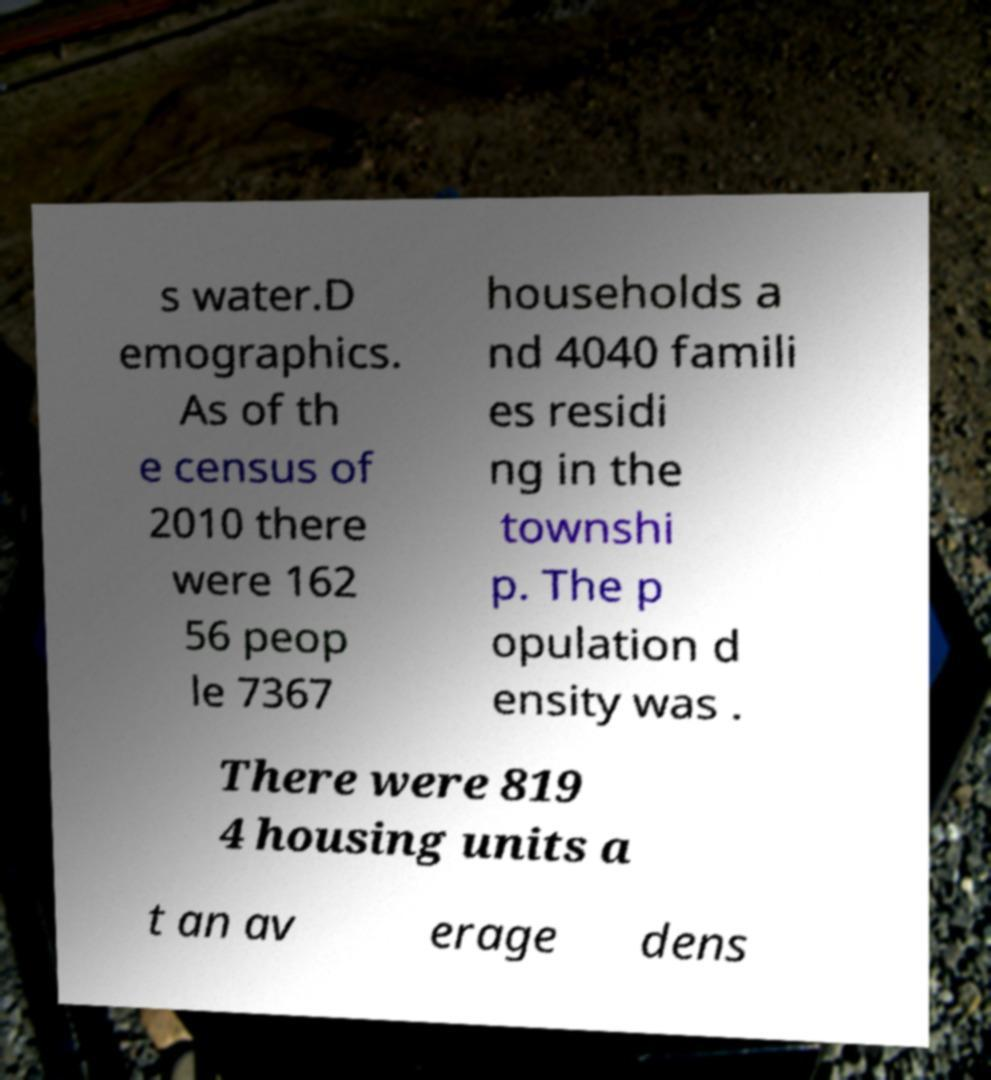Can you accurately transcribe the text from the provided image for me? s water.D emographics. As of th e census of 2010 there were 162 56 peop le 7367 households a nd 4040 famili es residi ng in the townshi p. The p opulation d ensity was . There were 819 4 housing units a t an av erage dens 